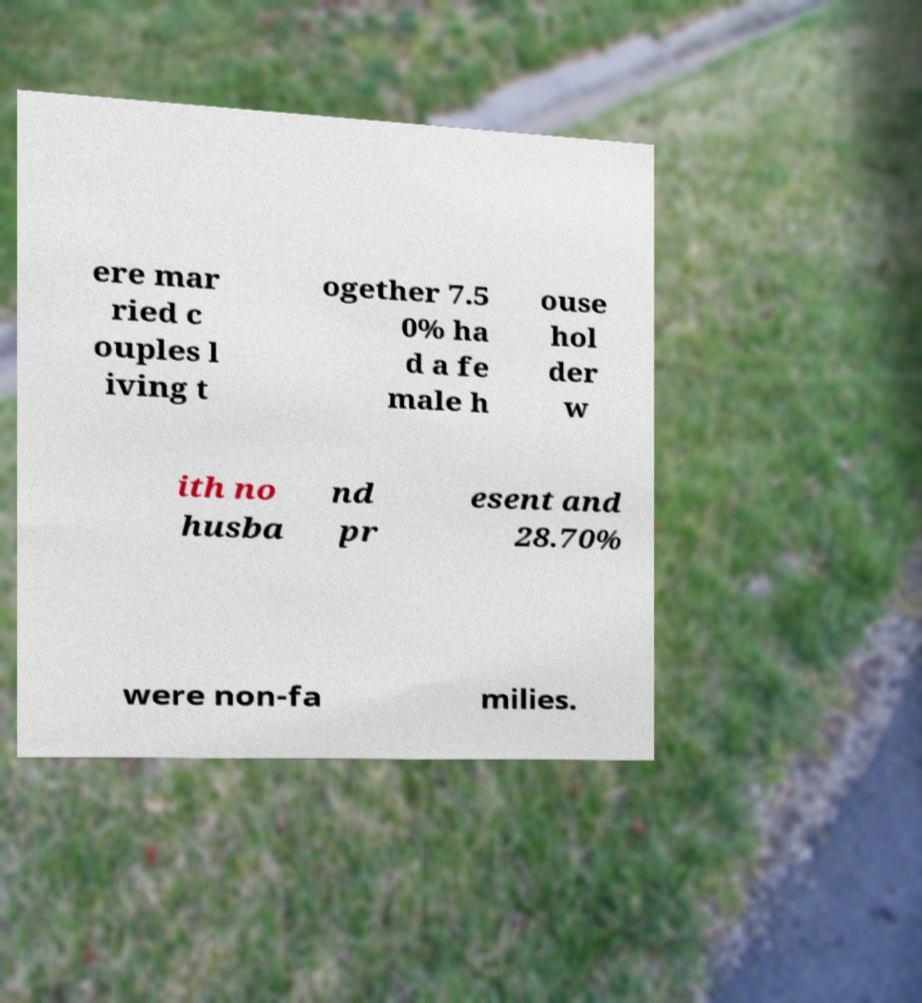Can you accurately transcribe the text from the provided image for me? ere mar ried c ouples l iving t ogether 7.5 0% ha d a fe male h ouse hol der w ith no husba nd pr esent and 28.70% were non-fa milies. 